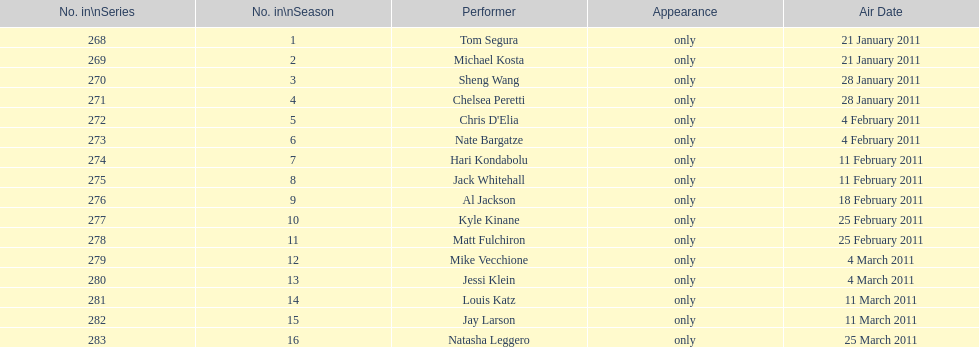Which month had the most air dates? February. 